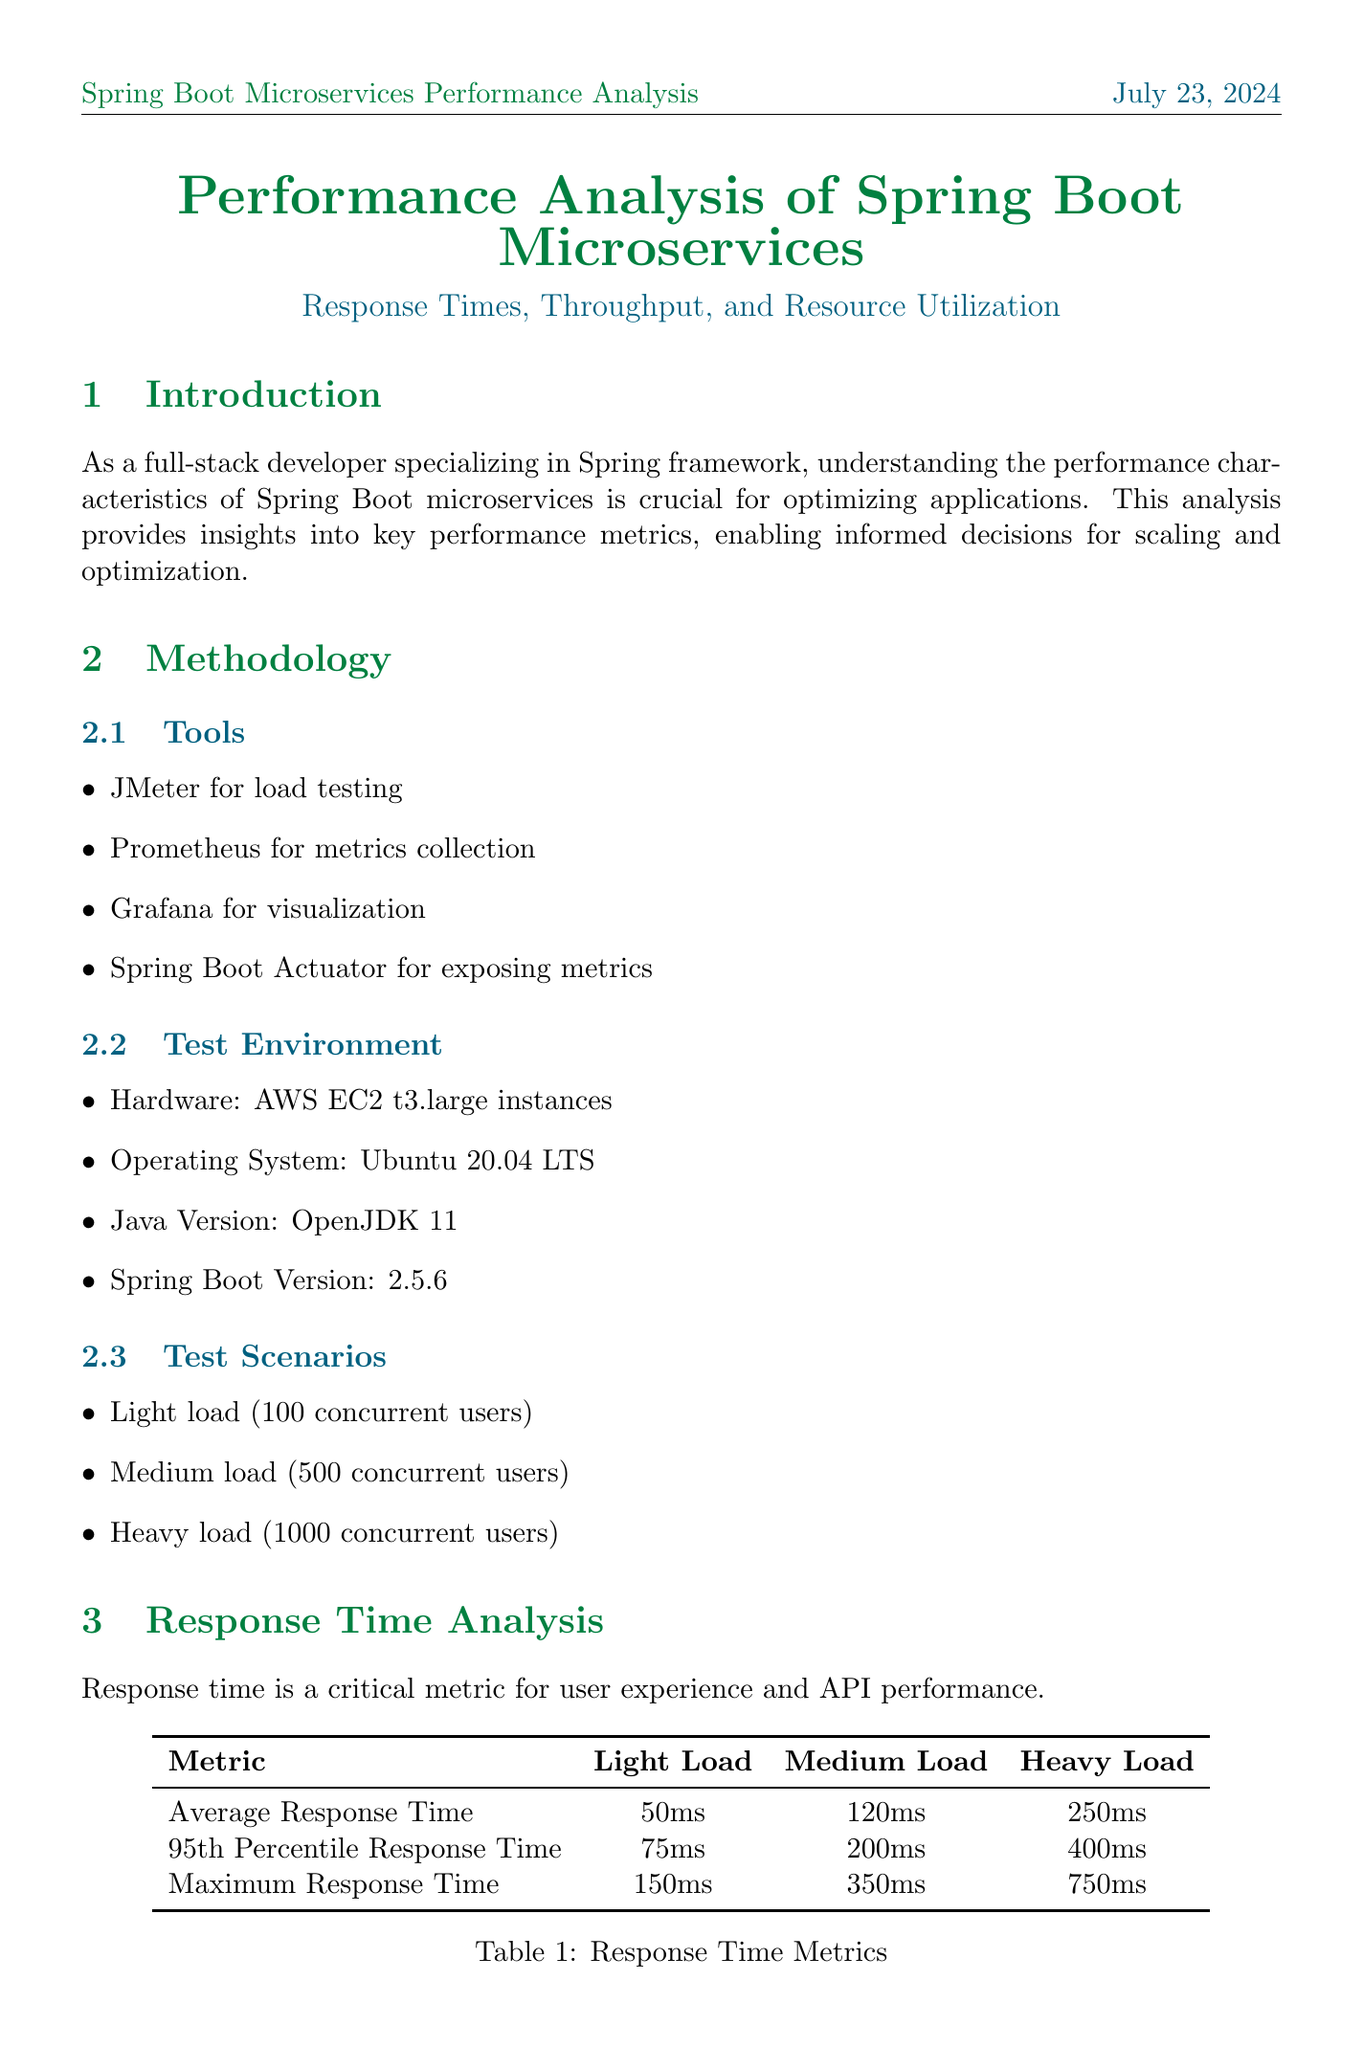What is the average response time under heavy load? The average response time under heavy load is obtained from the results section, which states that it is 250ms.
Answer: 250ms What tool is used for metrics collection? The tool for metrics collection is specified in the methodology section as Prometheus.
Answer: Prometheus What is the CPU usage during medium load? The CPU usage during medium load is stated in the resource utilization section as 60%.
Answer: 60% What is the expected impact of implementing caching? The expected impact of implementing caching includes a 30% reduction in database queries and a 20% improvement in average response time.
Answer: 30% reduction in database queries and 20% improvement in average response time What is the maximum response time under light load? The maximum response time under light load is derived from the corresponding section and is indicated as 150ms.
Answer: 150ms How many transactions per second are processed under heavy load? The number of transactions per second under heavy load is mentioned in the throughput analysis section as 3200.
Answer: 3200 What frequency of garbage collection is observed under light load? The frequency of garbage collection under light load is detailed in the resource utilization section, which states that it occurs every 5 minutes.
Answer: Every 5 minutes What Java version is utilized in the test environment? The Java version used in the test environment is specified in the methodology section, which is OpenJDK 11.
Answer: OpenJDK 11 What does the performance analysis reveal about microservices under heavy load? The performance analysis summary indicates that there is some degradation under heavy load for the Spring Boot microservices.
Answer: Some degradation under heavy load 